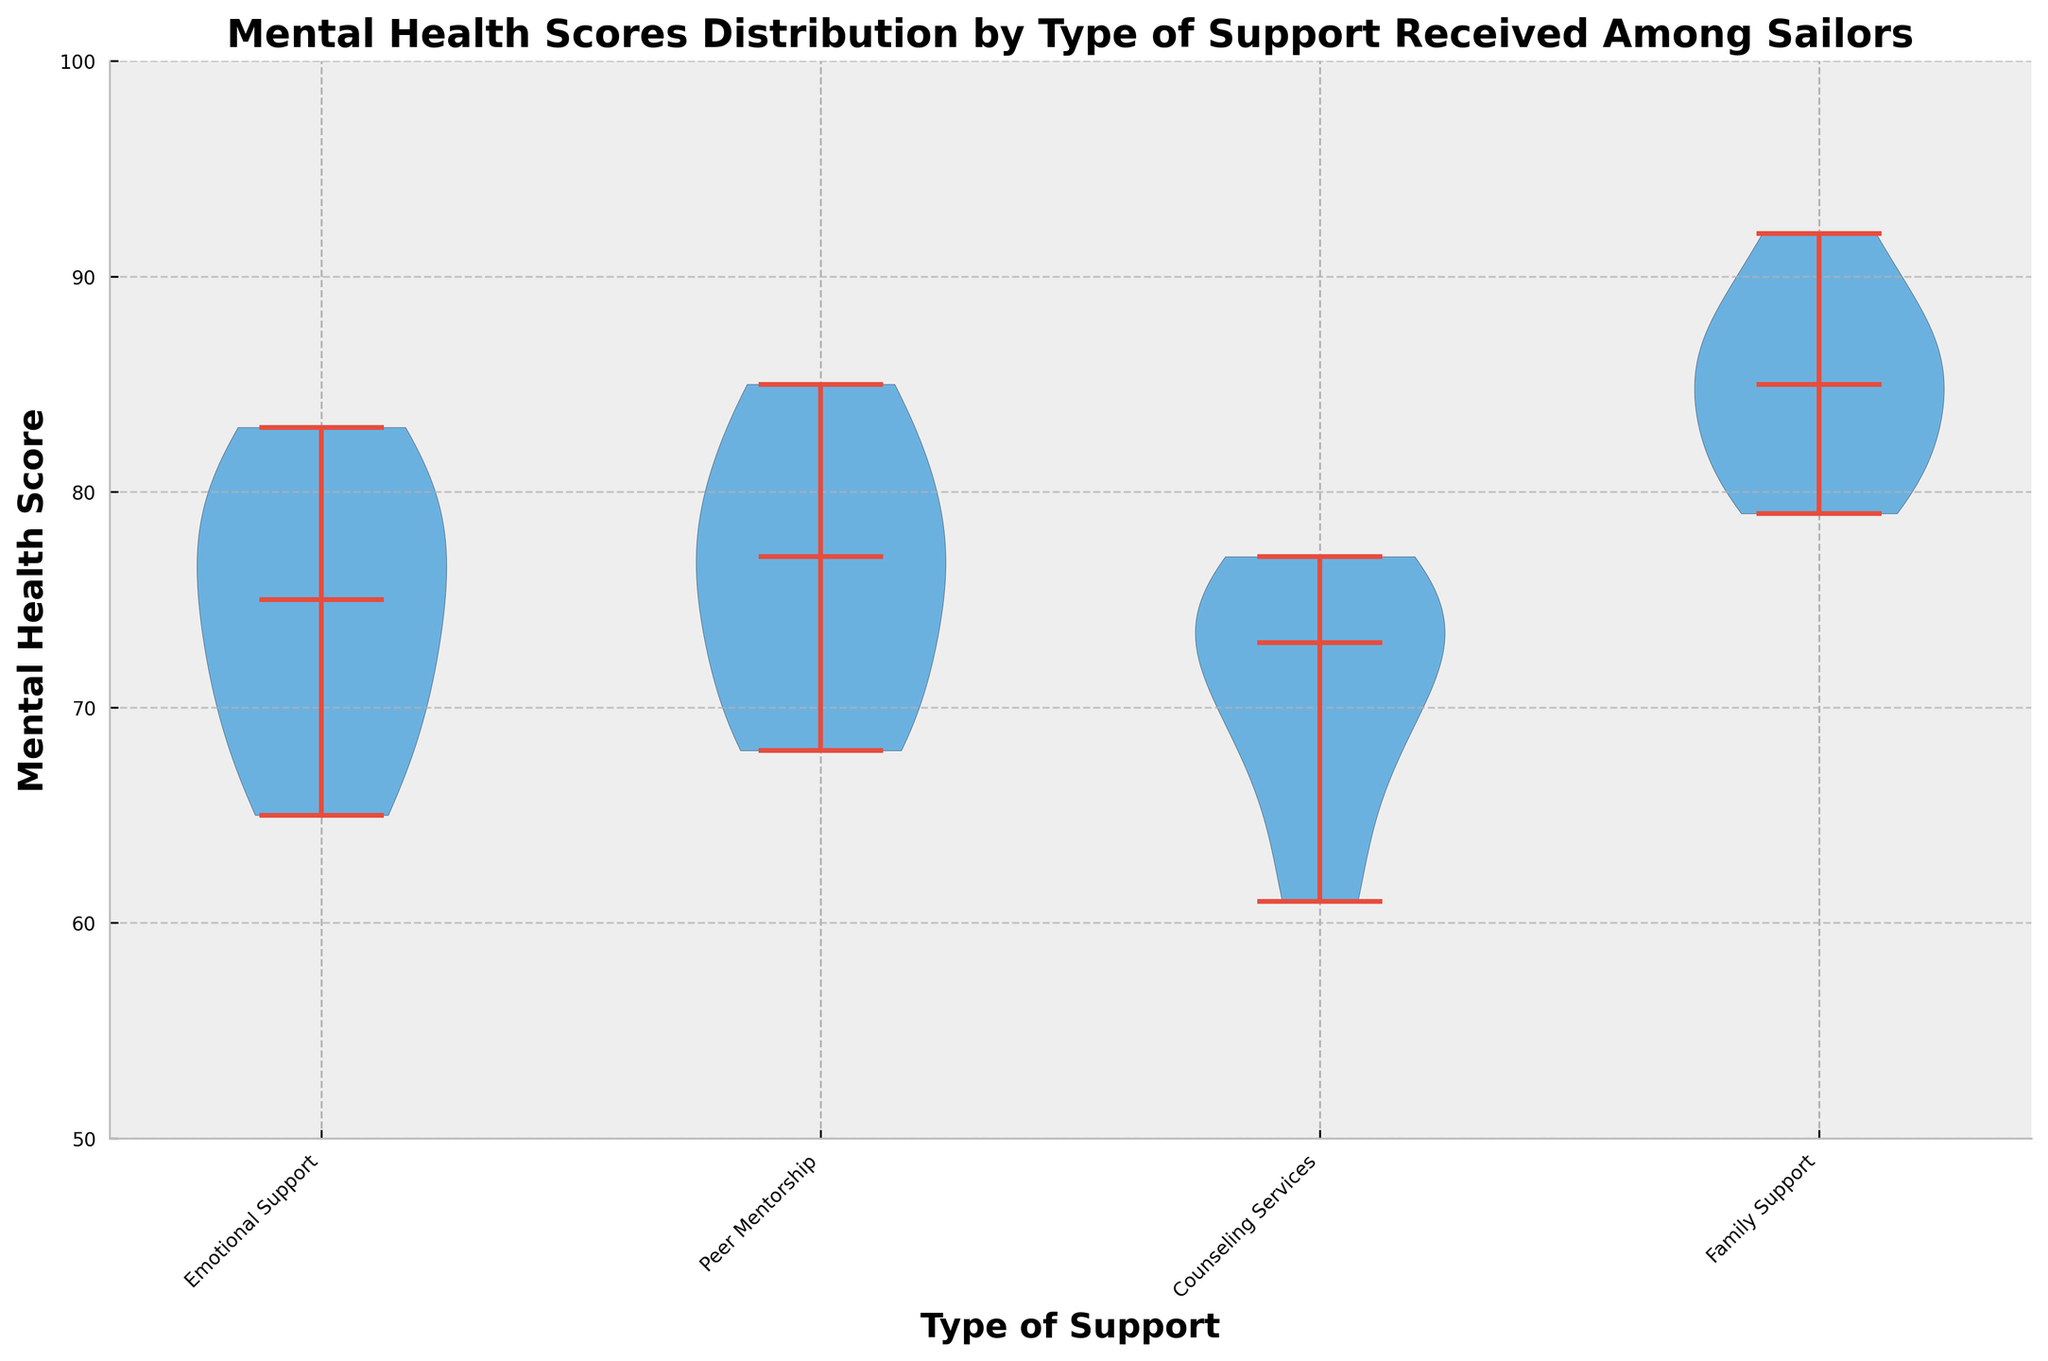What's the title of the plot? The title of the plot is located at the top of the figure and usually summarizes the main point or focus of the chart.
Answer: Mental Health Scores Distribution by Type of Support Received Among Sailors How many types of support are shown in the plot? The x-axis of the plot shows different categories of support types. Each category is labeled at the bottom. By counting these labels, you can determine the number of support types.
Answer: 4 Which type of support has the highest median mental health score? The median is represented by the horizontal line inside each violin plot. By comparing the positions of these lines across different support types, you can identify the highest median.
Answer: Family Support What is the range of mental health scores for Counseling Services? The range of scores can be determined by identifying the lowest and highest points on the y-axis within the Counseling Services violin plot. Look for the tips of the violin extending furthest up and down.
Answer: 61 to 77 How do Emotional Support and Peer Mentorship compare in terms of score distribution? By looking at the width and shape of the violin plots, note the spread and distribution of scores. Compare the shapes and spans of the plots above and below the median lines.
Answer: Emotional Support has a wider spread with scores ranging from 65 to 83, while Peer Mentorship is slightly narrower with scores from 68 to 85 What is the median score for Emotional Support? The median score is represented by the horizontal line inside each violin plot. Locate this line within the Emotional Support category to read off the median score.
Answer: 75 Between Counseling Services and Family Support, which has a tighter score distribution? Tighter distribution can be seen by the compactness of the violin plot. Narrower plots indicate less variation in scores. Compare the overall shapes of Counseling Services and Family Support.
Answer: Family Support Which support type shows the most variability in mental health scores? The most variable distribution will have the widest violin plot, indicating a broad range of scores. Compare the width of all violin plots to determine this.
Answer: Emotional Support What is the approximate interquartile range for Peer Mentorship scores? The interquartile range (IQR) can be approximated by visually estimating the width of the central portion of the violin plot around the median. Identify the region where the plot is thickest.
Answer: Approximately 70 to 78 Which support type likely has the highest upper extreme score? The highest upper extreme score is indicated by the point where the violin plot extends furthest on the y-axis. Compare this extreme across all support types.
Answer: Family Support 